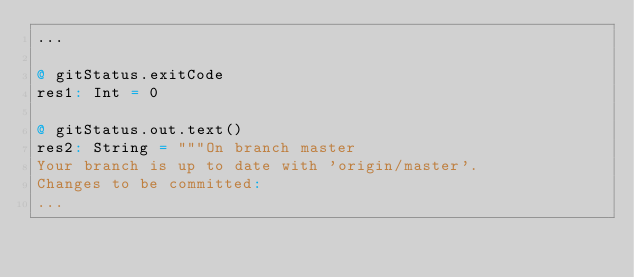Convert code to text. <code><loc_0><loc_0><loc_500><loc_500><_Scala_>...

@ gitStatus.exitCode
res1: Int = 0

@ gitStatus.out.text()
res2: String = """On branch master
Your branch is up to date with 'origin/master'.
Changes to be committed:
...
</code> 